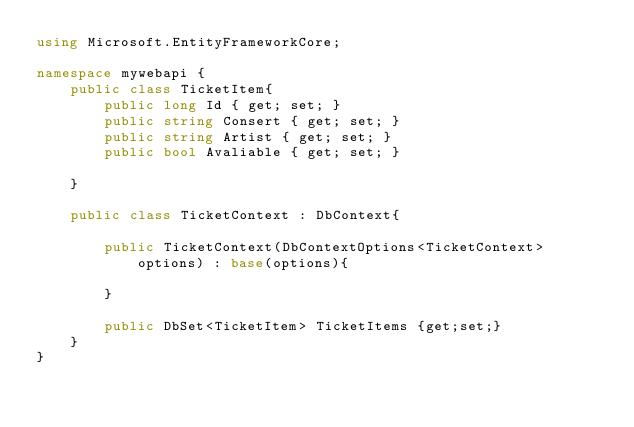<code> <loc_0><loc_0><loc_500><loc_500><_C#_>using Microsoft.EntityFrameworkCore;

namespace mywebapi {
    public class TicketItem{
        public long Id { get; set; }
        public string Consert { get; set; }
        public string Artist { get; set; }
        public bool Avaliable { get; set; }

    }

    public class TicketContext : DbContext{

        public TicketContext(DbContextOptions<TicketContext> options) : base(options){

        }

        public DbSet<TicketItem> TicketItems {get;set;}
    }
}</code> 